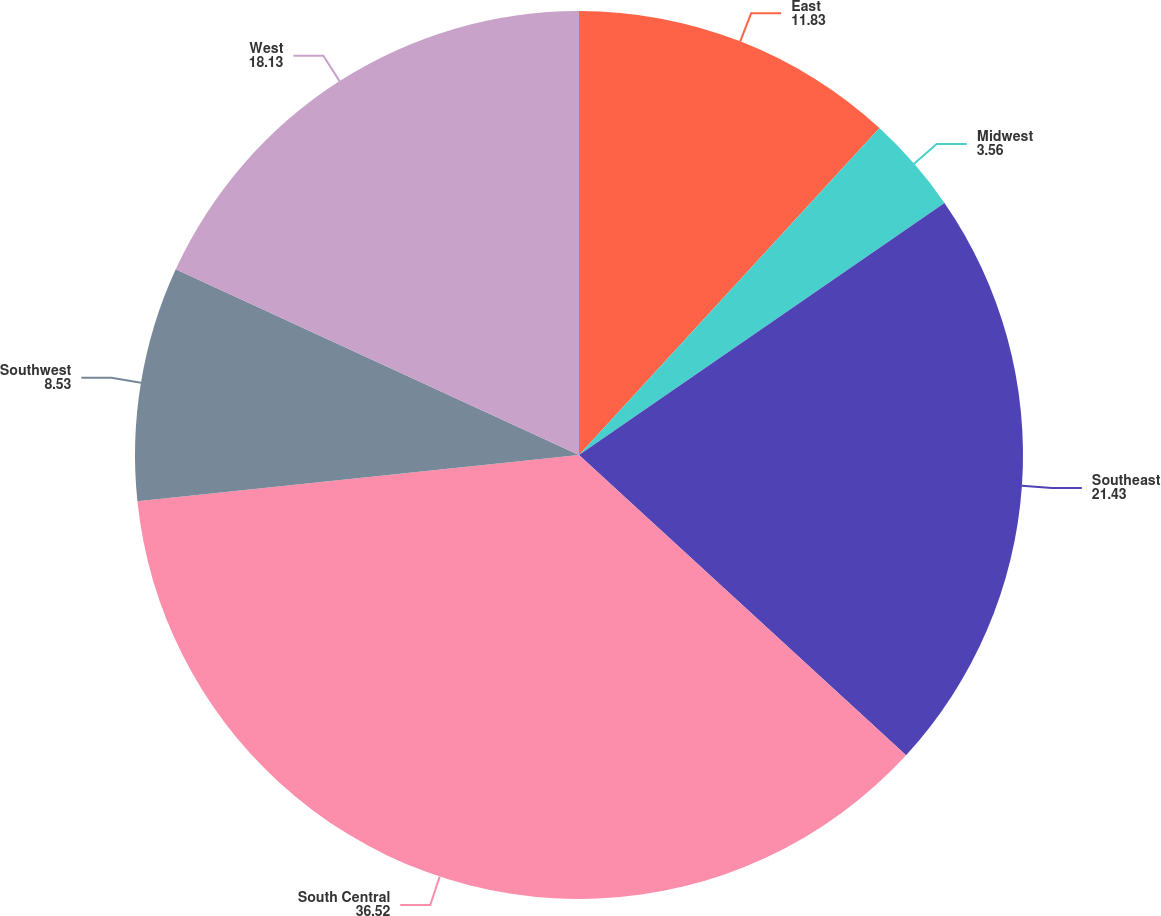Convert chart. <chart><loc_0><loc_0><loc_500><loc_500><pie_chart><fcel>East<fcel>Midwest<fcel>Southeast<fcel>South Central<fcel>Southwest<fcel>West<nl><fcel>11.83%<fcel>3.56%<fcel>21.43%<fcel>36.52%<fcel>8.53%<fcel>18.13%<nl></chart> 